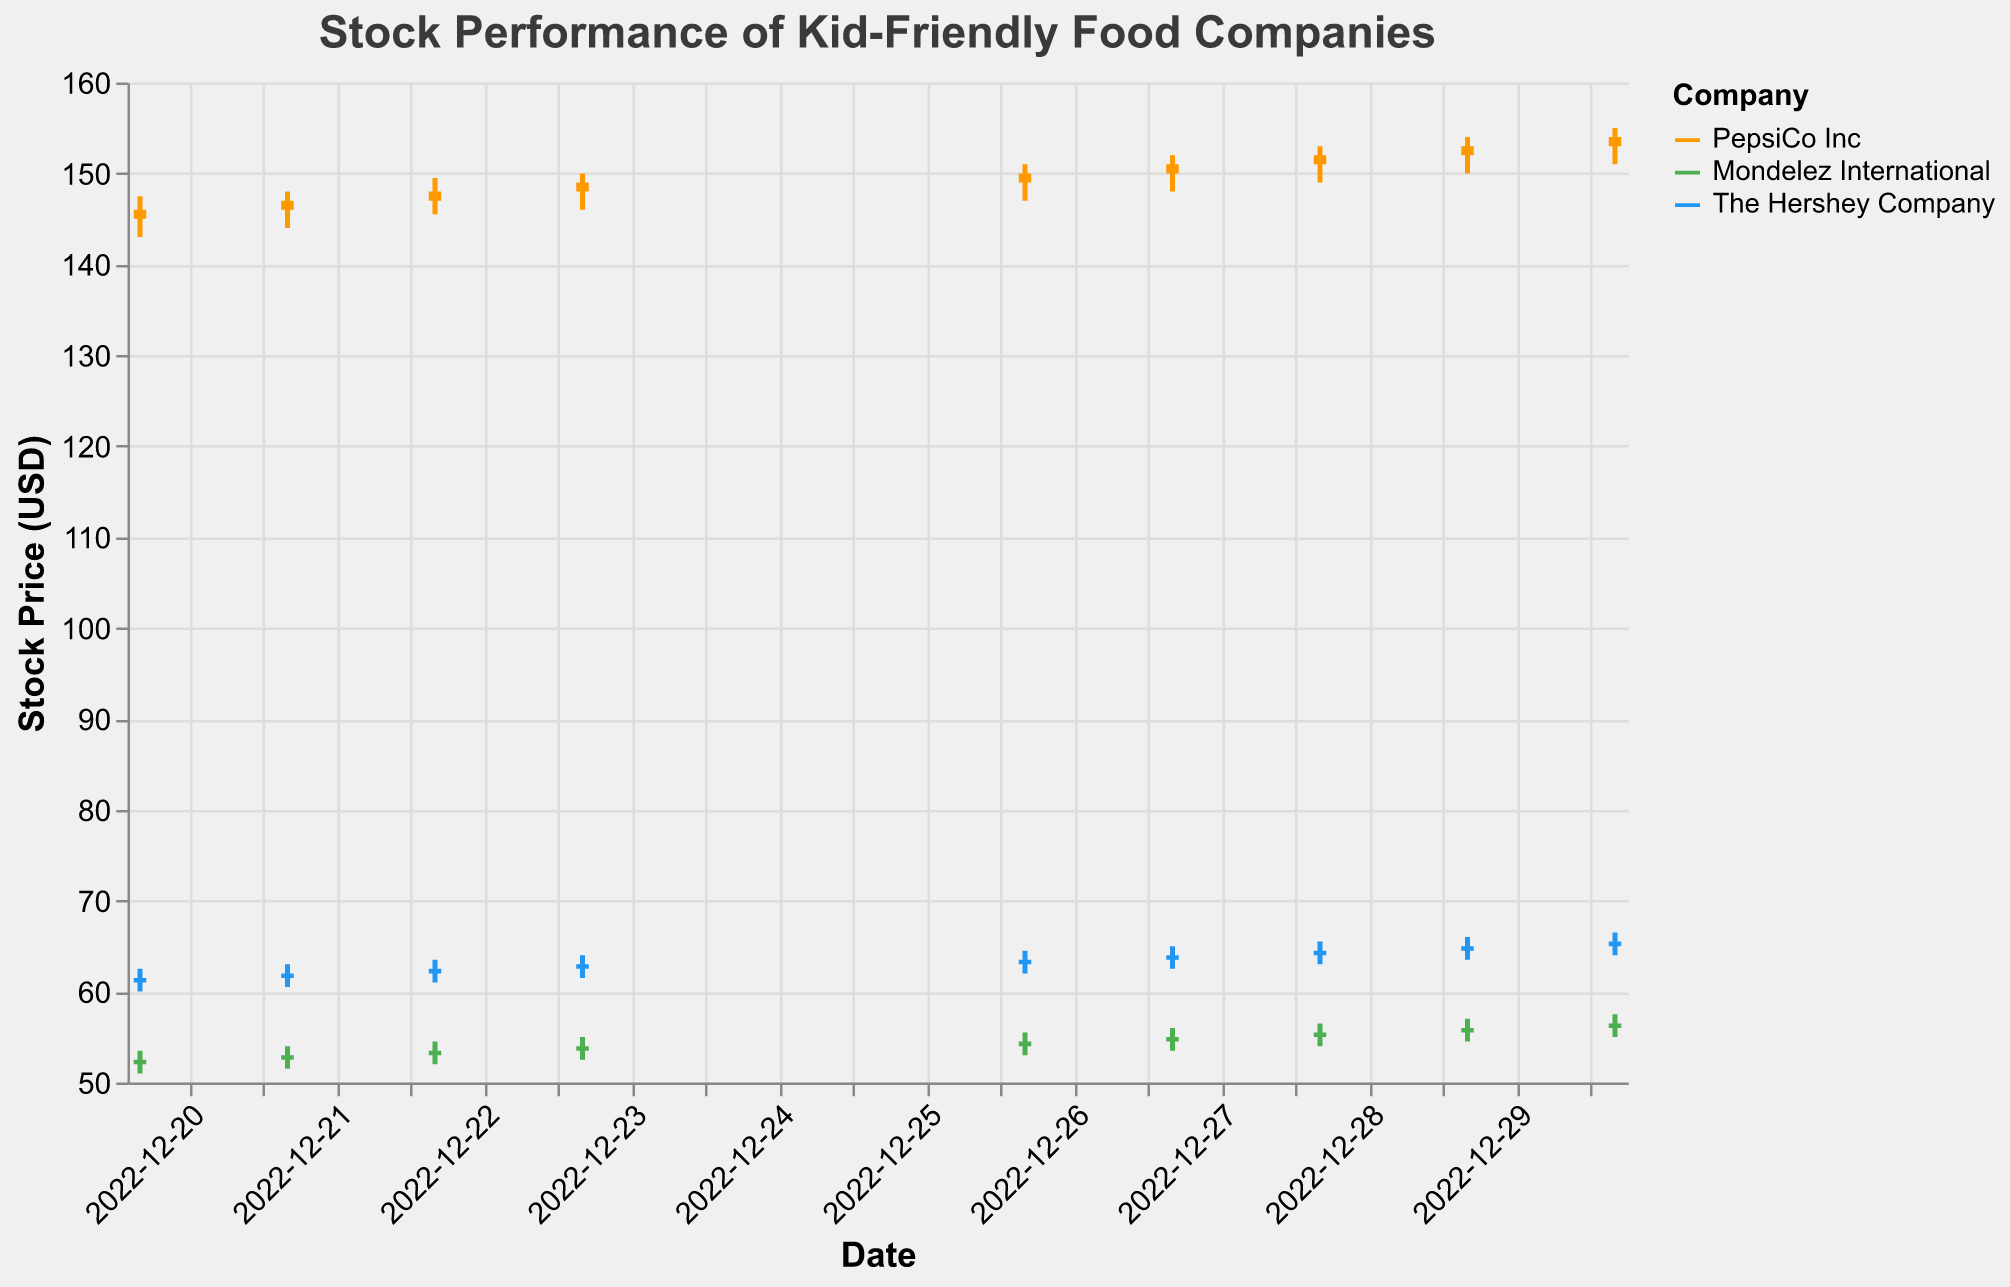What companies are represented in the plot? The legend in the figure shows color representations for three companies: PepsiCo Inc, Mondelez International, and The Hershey Company.
Answer: PepsiCo Inc, Mondelez International, The Hershey Company What is the overall trend in stock prices for PepsiCo Inc during the displayed period? By looking at the candlesticks, we can see that the stock price for PepsiCo Inc generally increased from an open price of 145.00 on December 20th to a closing price of 154.00 on December 30th.
Answer: Increasing trend On which date did The Hershey Company's stock close at its highest value? By examining the 'Close' prices for The Hershey Company, the stock closed at its highest value of 65.50 on December 30th.
Answer: December 30th Which company had the highest volume traded on December 30th? The volumes for December 30th are 1420000 for PepsiCo Inc, 2450000 for Mondelez International, and 2100000 for The Hershey Company. Mondelez International had the highest volume traded.
Answer: Mondelez International Compare the highest closing prices between Mondelez International and The Hershey Company. Which one was higher? By comparing the 'Close' prices, Mondelez International's highest closing price was 56.50 on December 30th, while The Hershey Company's highest closing price was 65.50 on the same day. The Hershey Company had the higher closing price.
Answer: The Hershey Company What was the difference in closing prices for PepsiCo Inc between December 23rd and December 30th? The closing price for PepsiCo Inc on December 23rd was 149.00, and on December 30th, it was 154.00. The difference is 154.00 - 149.00 = 5.00.
Answer: 5.00 Calculate the average closing price for Mondelez International during this period. Summing the closing prices for Mondelez International over the 9 days (52.50, 53.00, 53.50, 54.00, 54.50, 55.00, 55.50, 56.00, 56.50) is 490.50. The average is 490.50 / 9 = 54.50.
Answer: 54.50 Which company showed the most consistent daily increase in stock prices? By evaluating the candlestick trends, PepsiCo Inc showed a consistent day-to-day increase in its stock prices with relatively smaller fluctuations compared to the other companies.
Answer: PepsiCo Inc 